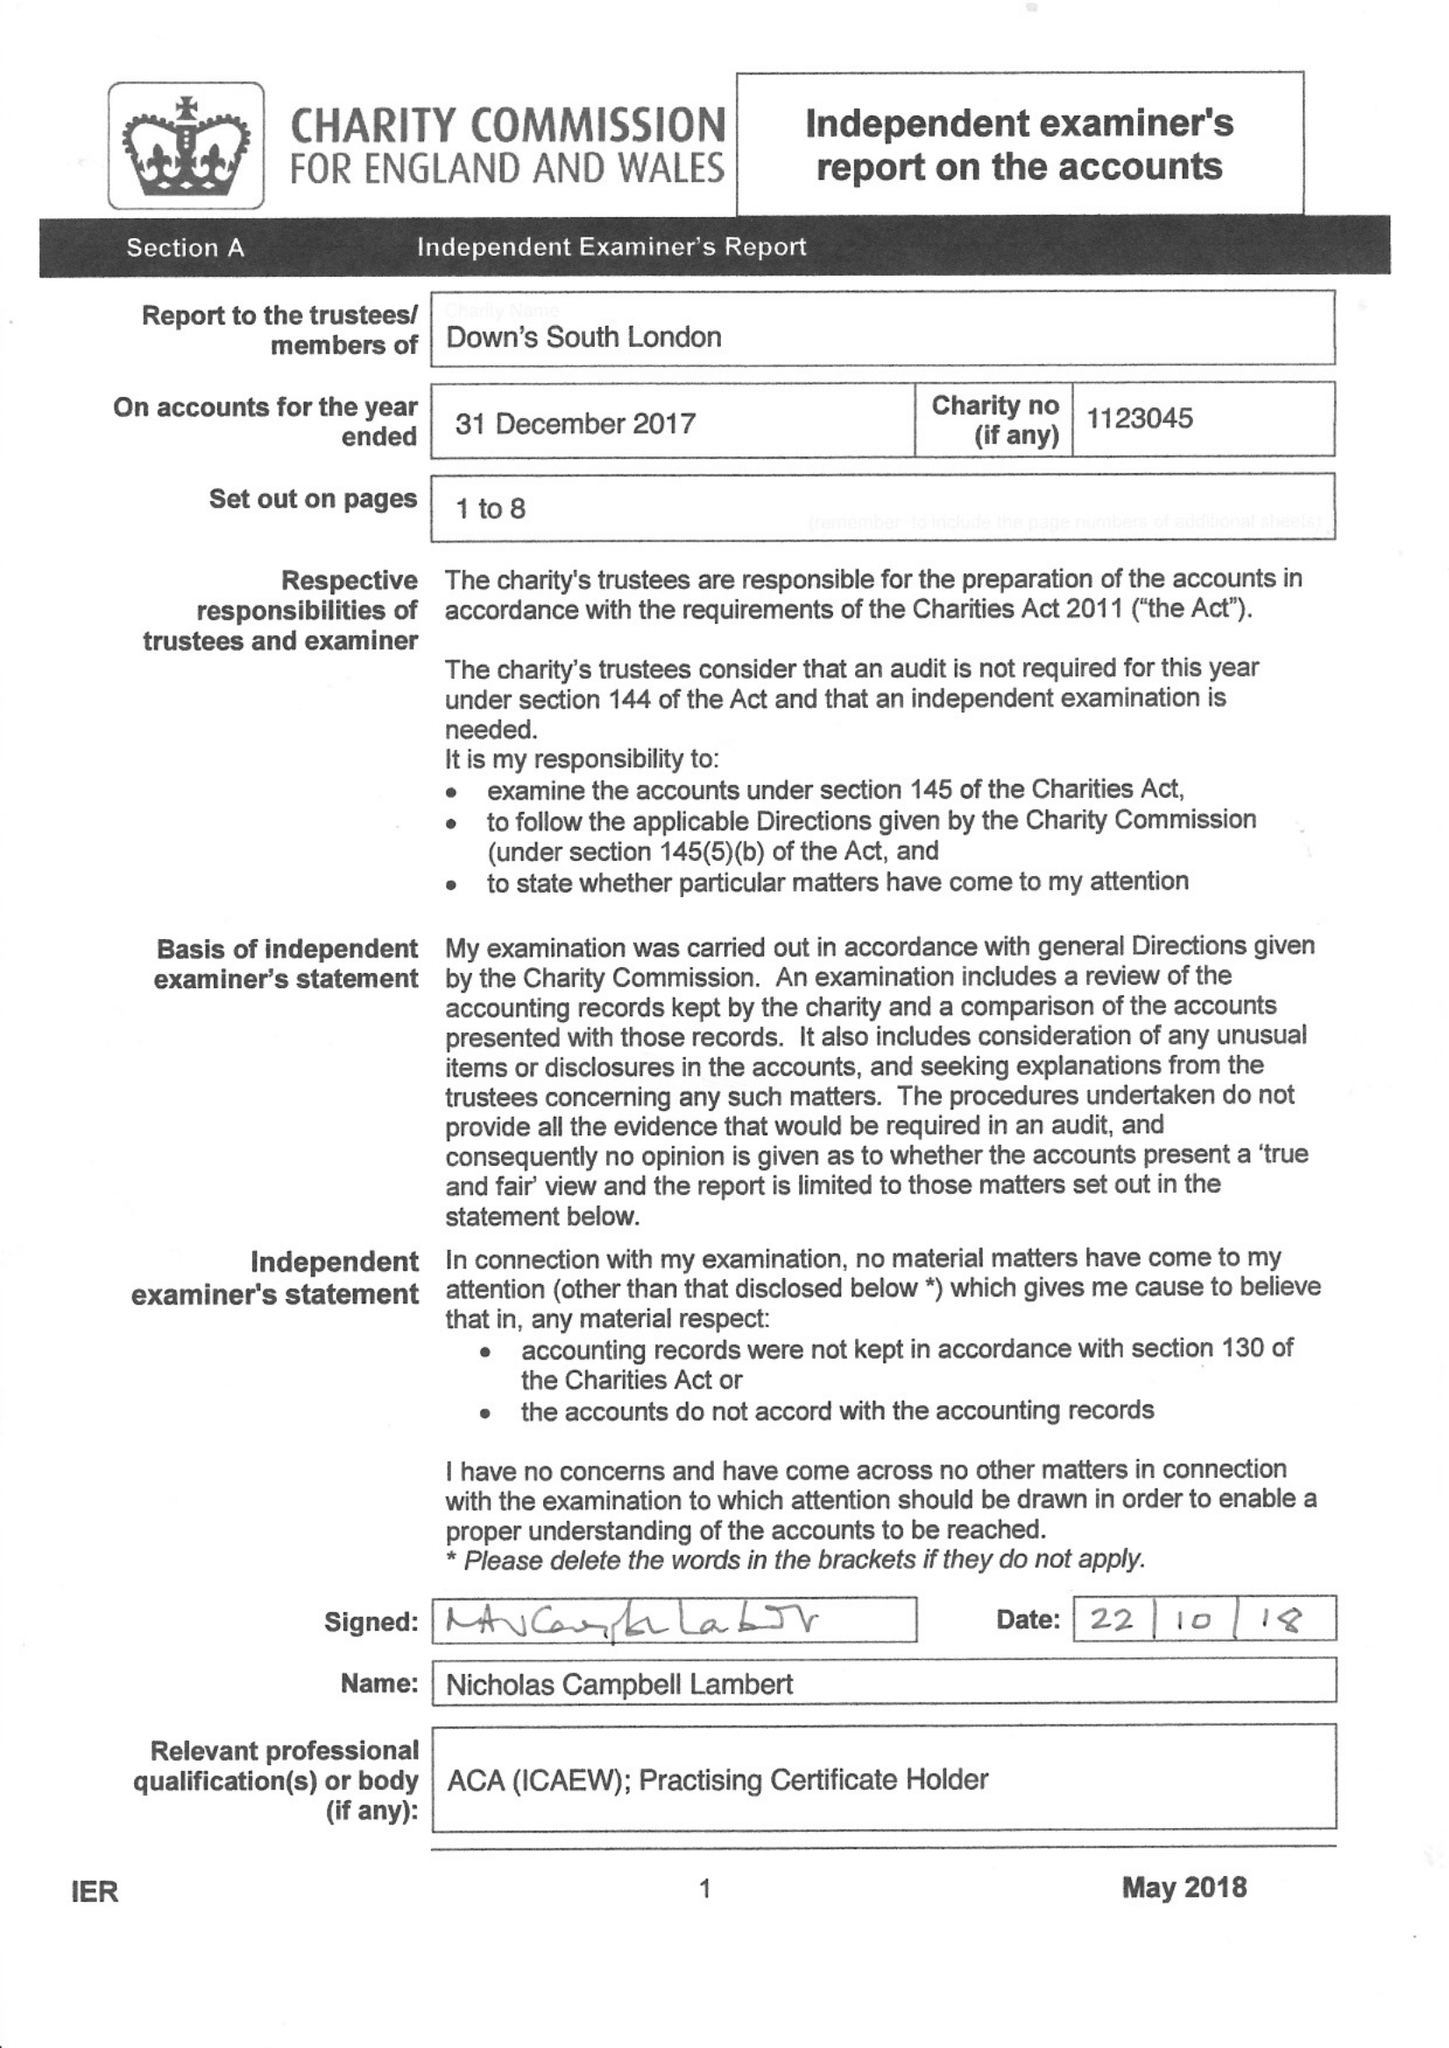What is the value for the income_annually_in_british_pounds?
Answer the question using a single word or phrase. 122754.00 